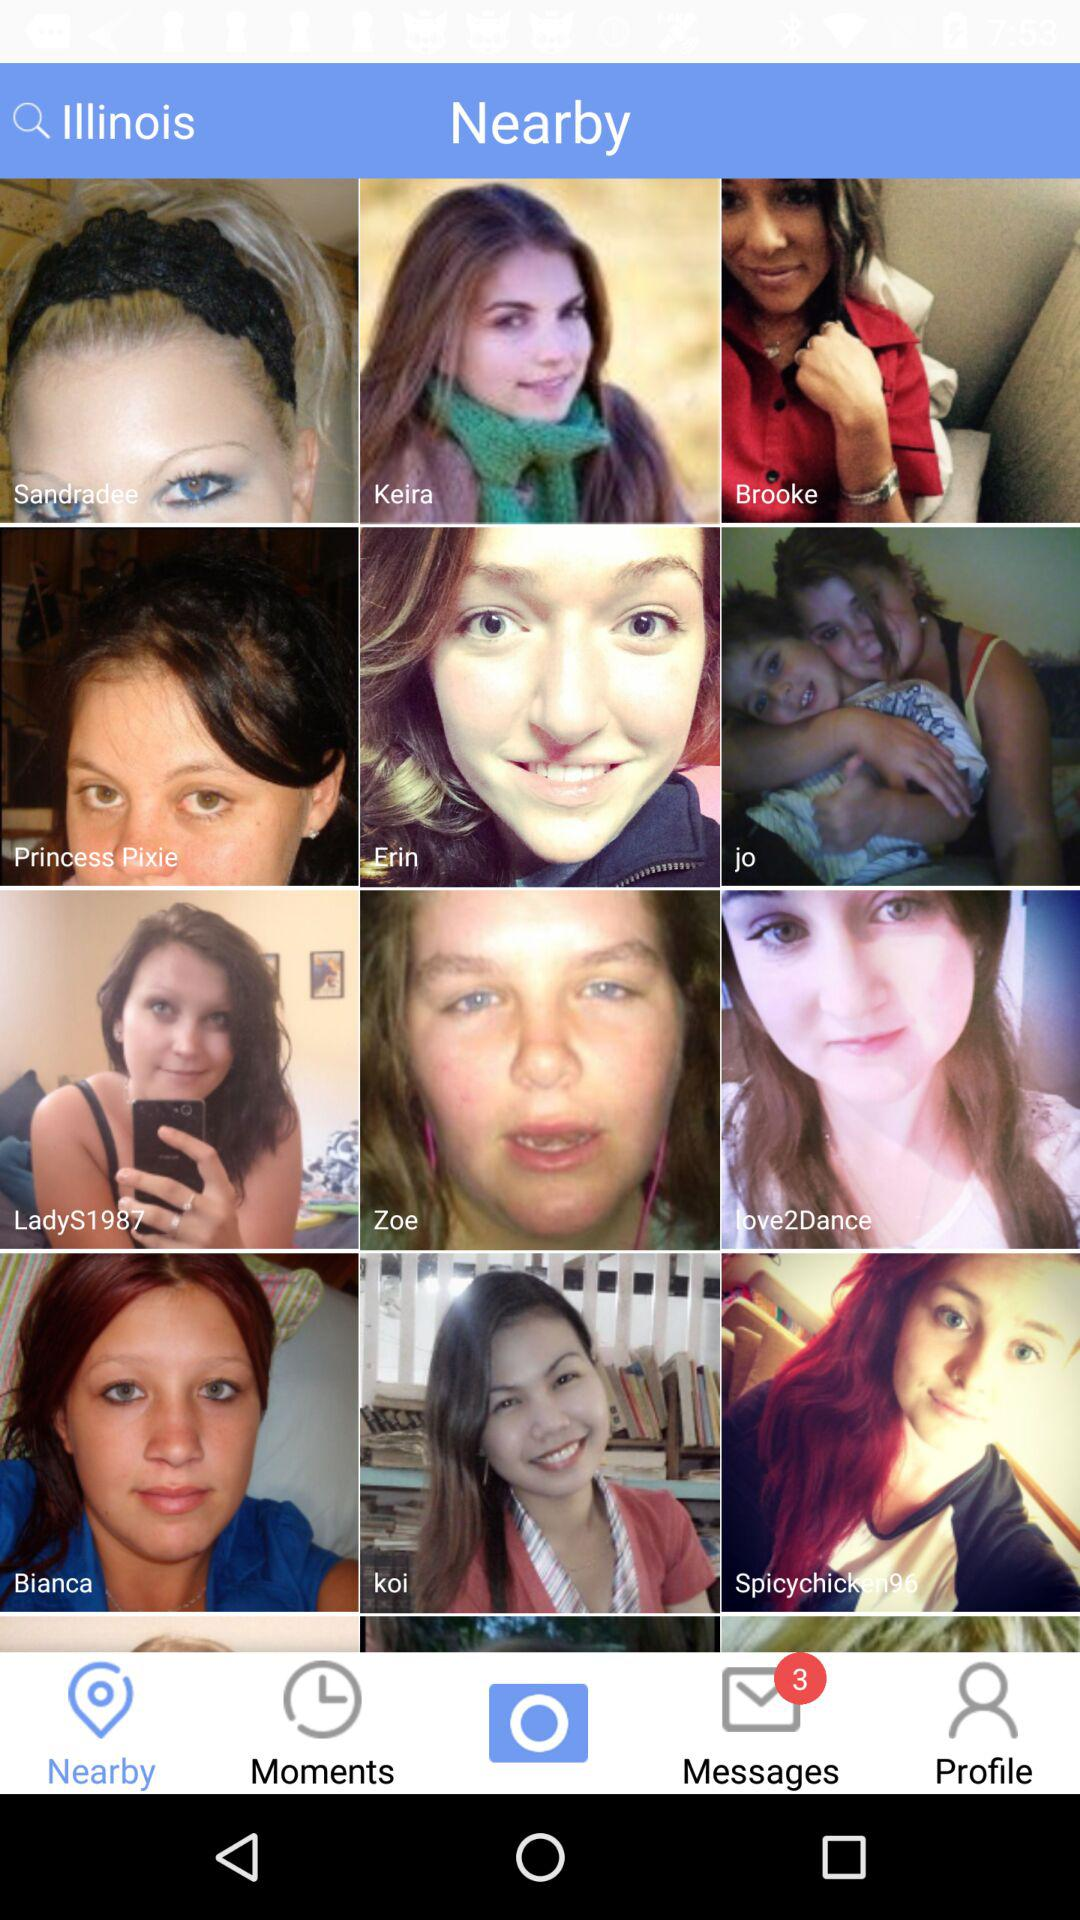How many messages are unread? There are 3 unread messages. 